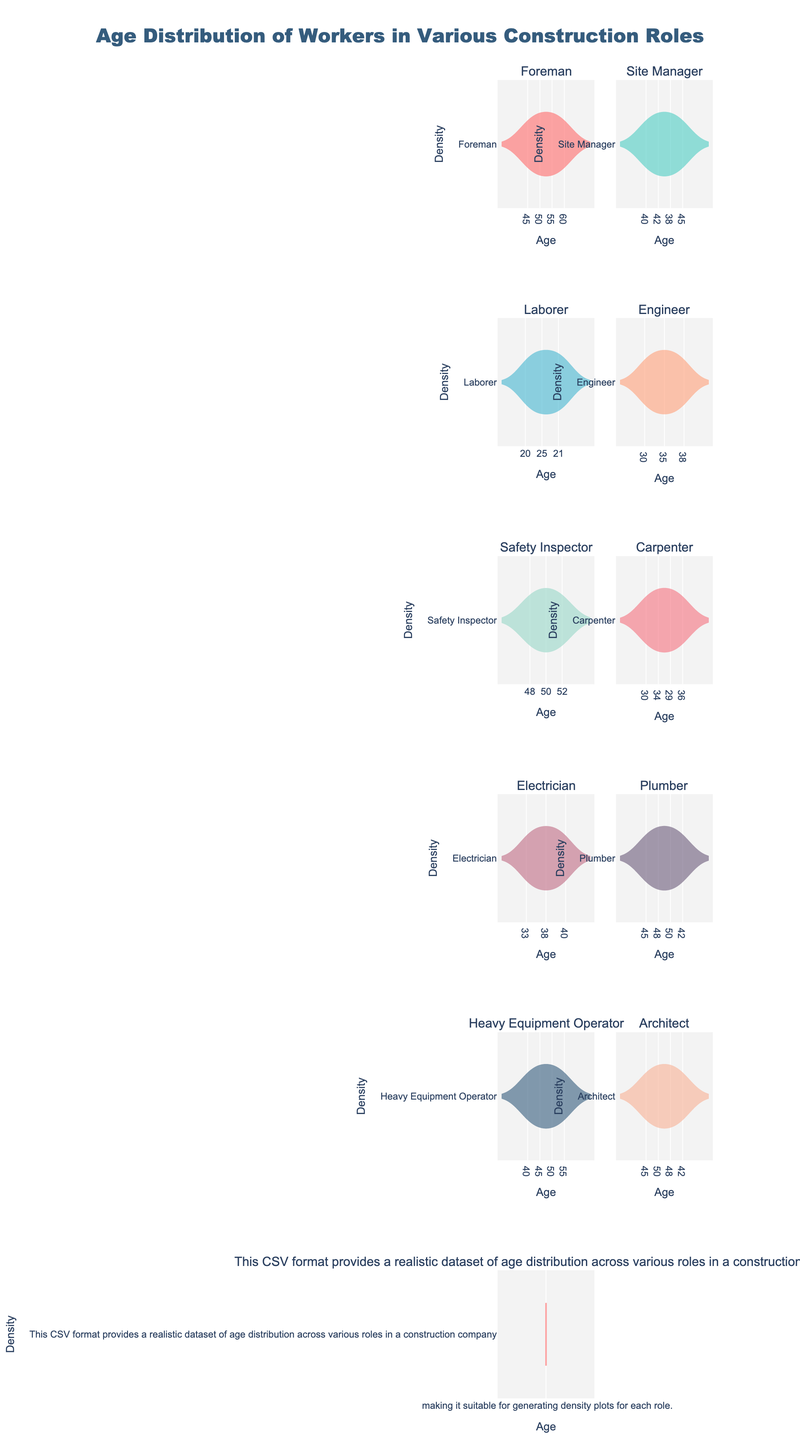What is the title of the figure? The title of the figure is situated at the top center of the plot. It provides an overview of what the entire subplot is about.
Answer: Age Distribution of Workers in Various Construction Roles Which role has the youngest group of workers? By observing the age ranges displayed in each subplot, we can see that the Laborer role has the youngest group of workers, with ages ranging from 20 to 28.
Answer: Laborer Compare the age distributions of Foremen and Site Managers. Looking at the individual density plots for Foremen and Site Managers, Foremen have an age range primarily between 45 and 60, while Site Managers range from 38 to 45. Both roles have overlapping ages but focus on slightly different age groups.
Answer: Foremen: 45-60, Site Managers: 38-45 Which role has the highest density of workers around the age of 40? To determine this, we examine all the density plots to see where the highest peaks around the age of 40 are. The Engineer and Heavy Equipment Operator roles both show high densities around this age.
Answer: Engineer and Heavy Equipment Operator What is the median age for the Electricians? The median can be estimated by looking at the center of the density plot for Electricians. The highest density area is around the ages 35 to 38, but the middle range suggests a median age of around 37.
Answer: 37 How does the age distribution of Carpenters compare to that of Engineers? From the density plots, Carpenters have an age distribution primarily from 29 to 36, while Engineers range more broadly from 30 to 40. Carpenters have a tighter distribution, whereas Engineers show a wider spread.
Answer: Carpenters: 29-36, Engineers: 30-40 Which roles have overlapping age distributions? Examining the density plots, we see that Electricians and Engineers, as well as Foremen and Heavy Equipment Operators, have overlapping age distributions, especially around the ages 35 to 40 and 45 to 50 respectively.
Answer: Electricians and Engineers; Foremen and Heavy Equipment Operators What is the average age of the Architect role? By observing the density plot of the Architect role, we see values roughly in the range of 42 to 50. Estimating the midpoint gives us an average age around 46.
Answer: 46 